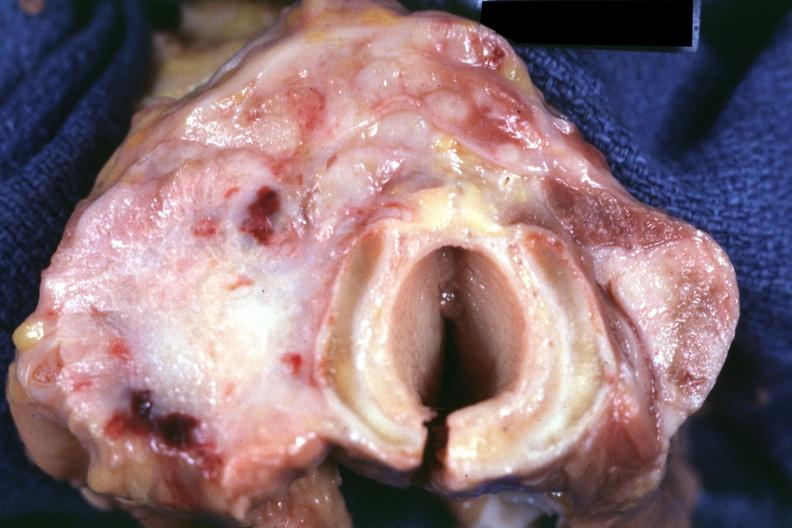s carcinoma present?
Answer the question using a single word or phrase. Yes 